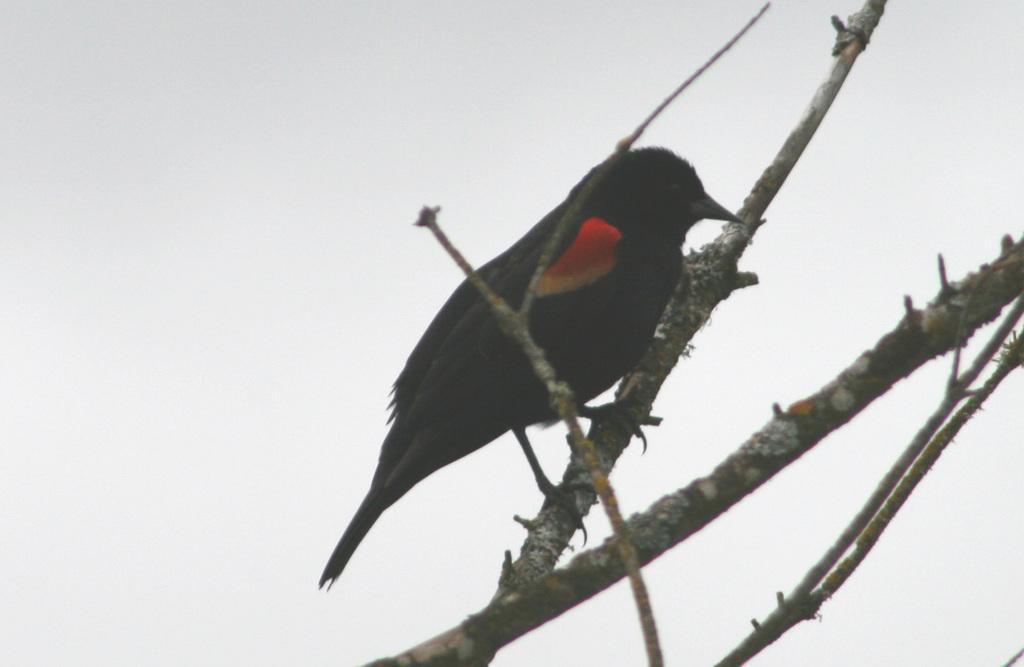In one or two sentences, can you explain what this image depicts? In this image, there is a bird sitting on a branch. 